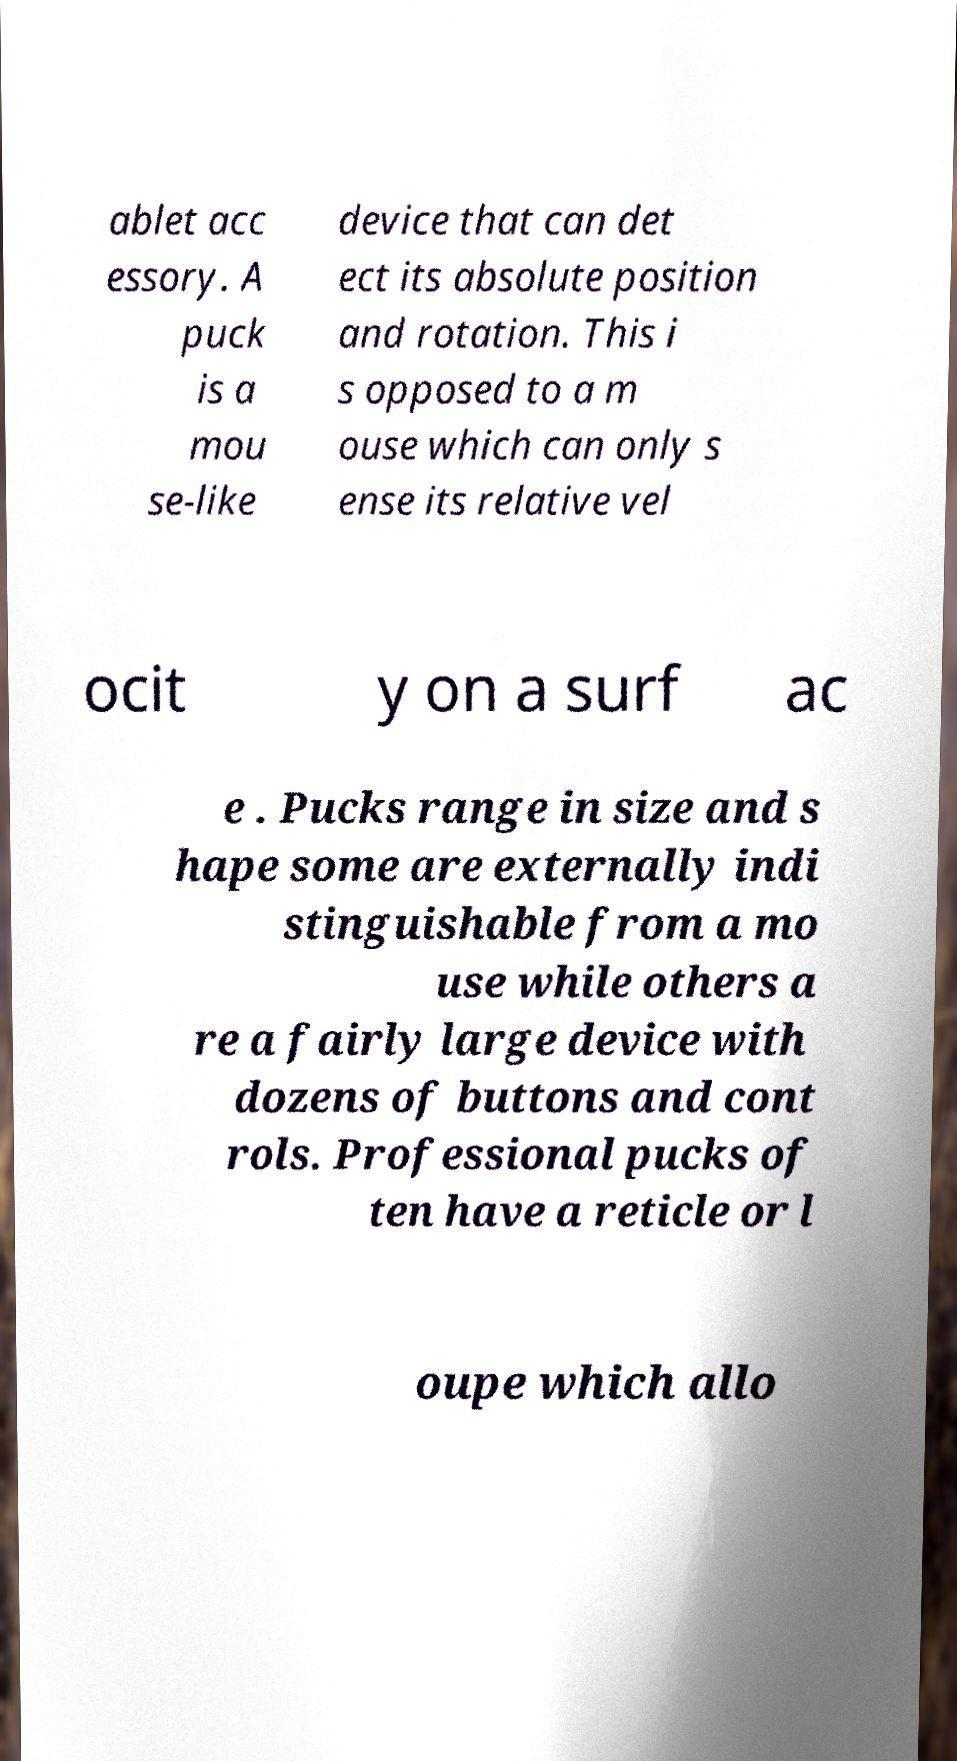What messages or text are displayed in this image? I need them in a readable, typed format. ablet acc essory. A puck is a mou se-like device that can det ect its absolute position and rotation. This i s opposed to a m ouse which can only s ense its relative vel ocit y on a surf ac e . Pucks range in size and s hape some are externally indi stinguishable from a mo use while others a re a fairly large device with dozens of buttons and cont rols. Professional pucks of ten have a reticle or l oupe which allo 